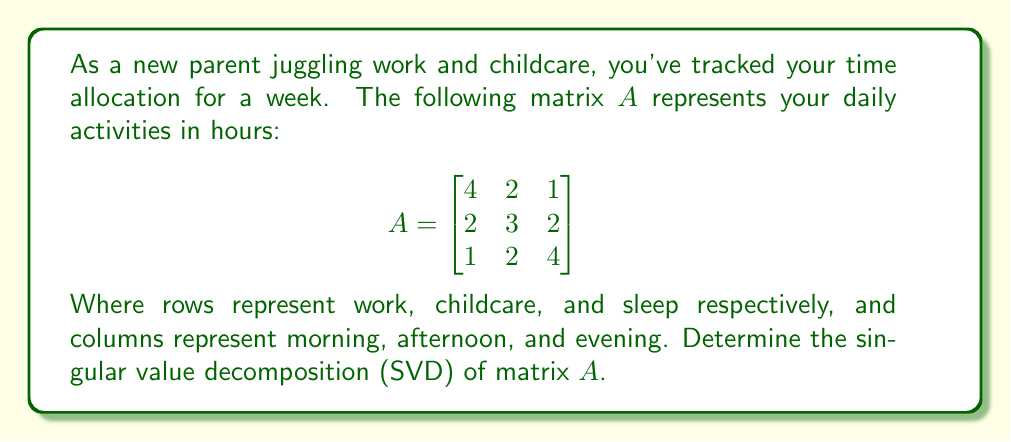Could you help me with this problem? To find the singular value decomposition of matrix $A$, we need to determine $A = U\Sigma V^T$, where $U$ and $V$ are orthogonal matrices and $\Sigma$ is a diagonal matrix with singular values.

Step 1: Calculate $A^TA$ and $AA^T$:

$$A^TA = \begin{bmatrix}
21 & 16 & 13 \\
16 & 17 & 14 \\
13 & 14 & 21
\end{bmatrix}$$

$$AA^T = \begin{bmatrix}
21 & 16 & 11 \\
16 & 17 & 14 \\
11 & 14 & 21
\end{bmatrix}$$

Step 2: Find eigenvalues of $A^TA$ (same as $AA^T$):
Characteristic equation: $\det(A^TA - \lambda I) = 0$
$\lambda^3 - 59\lambda^2 + 1083\lambda - 6125 = 0$
Solving this, we get: $\lambda_1 \approx 45.22$, $\lambda_2 \approx 12.07$, $\lambda_3 \approx 1.71$

Step 3: Calculate singular values:
$\sigma_1 = \sqrt{\lambda_1} \approx 6.72$
$\sigma_2 = \sqrt{\lambda_2} \approx 3.47$
$\sigma_3 = \sqrt{\lambda_3} \approx 1.31$

Step 4: Find eigenvectors of $A^TA$ for $V$:
$v_1 \approx [0.656, 0.567, 0.498]^T$
$v_2 \approx [-0.512, 0.814, -0.272]^T$
$v_3 \approx [-0.554, -0.124, 0.823]^T$

Step 5: Find eigenvectors of $AA^T$ for $U$:
$u_1 \approx [0.685, 0.579, 0.442]^T$
$u_2 \approx [-0.728, 0.682, 0.070]^T$
$u_3 \approx [-0.028, -0.447, 0.894]^T$

Step 6: Construct matrices $U$, $\Sigma$, and $V$:

$$U \approx \begin{bmatrix}
0.685 & -0.728 & -0.028 \\
0.579 & 0.682 & -0.447 \\
0.442 & 0.070 & 0.894
\end{bmatrix}$$

$$\Sigma \approx \begin{bmatrix}
6.72 & 0 & 0 \\
0 & 3.47 & 0 \\
0 & 0 & 1.31
\end{bmatrix}$$

$$V \approx \begin{bmatrix}
0.656 & -0.512 & -0.554 \\
0.567 & 0.814 & -0.124 \\
0.498 & -0.272 & 0.823
\end{bmatrix}$$
Answer: $A \approx U\Sigma V^T$, where:

$U \approx \begin{bmatrix}
0.685 & -0.728 & -0.028 \\
0.579 & 0.682 & -0.447 \\
0.442 & 0.070 & 0.894
\end{bmatrix}$

$\Sigma \approx \begin{bmatrix}
6.72 & 0 & 0 \\
0 & 3.47 & 0 \\
0 & 0 & 1.31
\end{bmatrix}$

$V \approx \begin{bmatrix}
0.656 & -0.512 & -0.554 \\
0.567 & 0.814 & -0.124 \\
0.498 & -0.272 & 0.823
\end{bmatrix}$ 